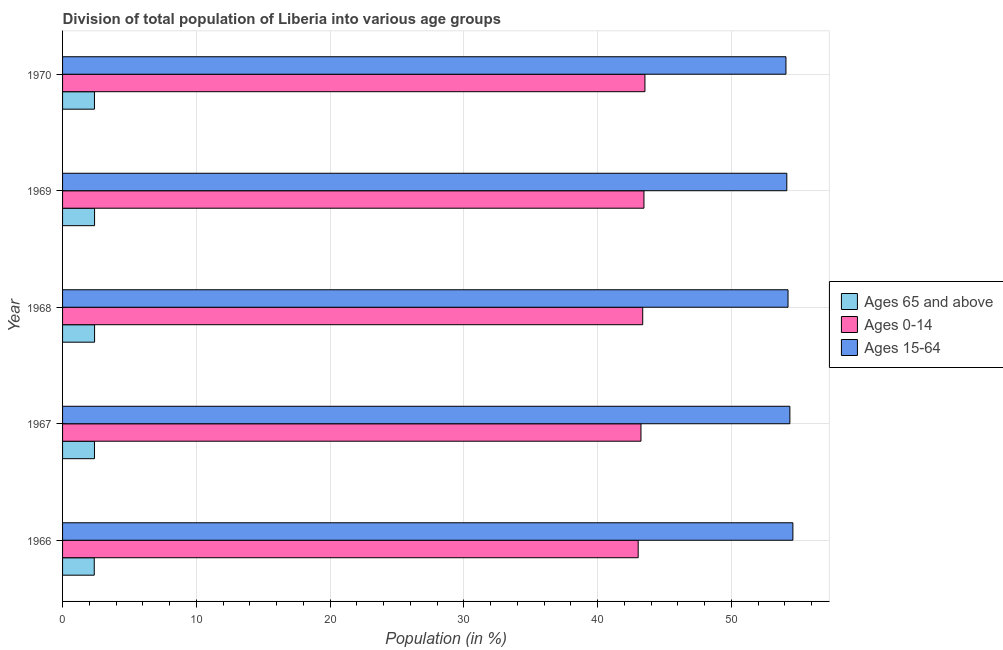How many different coloured bars are there?
Provide a succinct answer. 3. Are the number of bars per tick equal to the number of legend labels?
Offer a terse response. Yes. Are the number of bars on each tick of the Y-axis equal?
Provide a short and direct response. Yes. How many bars are there on the 1st tick from the bottom?
Your answer should be compact. 3. What is the label of the 1st group of bars from the top?
Offer a terse response. 1970. What is the percentage of population within the age-group 0-14 in 1970?
Provide a succinct answer. 43.54. Across all years, what is the maximum percentage of population within the age-group 15-64?
Provide a succinct answer. 54.6. Across all years, what is the minimum percentage of population within the age-group of 65 and above?
Provide a succinct answer. 2.37. In which year was the percentage of population within the age-group of 65 and above maximum?
Keep it short and to the point. 1968. In which year was the percentage of population within the age-group of 65 and above minimum?
Offer a terse response. 1966. What is the total percentage of population within the age-group 0-14 in the graph?
Give a very brief answer. 216.65. What is the difference between the percentage of population within the age-group 0-14 in 1968 and that in 1970?
Provide a short and direct response. -0.17. What is the difference between the percentage of population within the age-group 15-64 in 1970 and the percentage of population within the age-group 0-14 in 1966?
Keep it short and to the point. 11.05. What is the average percentage of population within the age-group 15-64 per year?
Provide a succinct answer. 54.29. In the year 1968, what is the difference between the percentage of population within the age-group 0-14 and percentage of population within the age-group of 65 and above?
Offer a very short reply. 40.98. In how many years, is the percentage of population within the age-group of 65 and above greater than 42 %?
Keep it short and to the point. 0. What is the ratio of the percentage of population within the age-group 0-14 in 1969 to that in 1970?
Provide a short and direct response. 1. Is the percentage of population within the age-group of 65 and above in 1968 less than that in 1969?
Ensure brevity in your answer.  No. What is the difference between the highest and the second highest percentage of population within the age-group 15-64?
Offer a very short reply. 0.23. What is the difference between the highest and the lowest percentage of population within the age-group of 65 and above?
Provide a short and direct response. 0.02. Is the sum of the percentage of population within the age-group of 65 and above in 1966 and 1969 greater than the maximum percentage of population within the age-group 15-64 across all years?
Give a very brief answer. No. What does the 1st bar from the top in 1969 represents?
Offer a very short reply. Ages 15-64. What does the 1st bar from the bottom in 1967 represents?
Keep it short and to the point. Ages 65 and above. How many bars are there?
Your answer should be compact. 15. How many years are there in the graph?
Offer a very short reply. 5. Are the values on the major ticks of X-axis written in scientific E-notation?
Offer a terse response. No. Does the graph contain any zero values?
Keep it short and to the point. No. Does the graph contain grids?
Make the answer very short. Yes. Where does the legend appear in the graph?
Offer a terse response. Center right. How are the legend labels stacked?
Make the answer very short. Vertical. What is the title of the graph?
Your answer should be very brief. Division of total population of Liberia into various age groups
. What is the label or title of the X-axis?
Your answer should be very brief. Population (in %). What is the Population (in %) of Ages 65 and above in 1966?
Your answer should be compact. 2.37. What is the Population (in %) of Ages 0-14 in 1966?
Make the answer very short. 43.03. What is the Population (in %) of Ages 15-64 in 1966?
Offer a very short reply. 54.6. What is the Population (in %) in Ages 65 and above in 1967?
Give a very brief answer. 2.39. What is the Population (in %) in Ages 0-14 in 1967?
Provide a short and direct response. 43.24. What is the Population (in %) of Ages 15-64 in 1967?
Your answer should be compact. 54.37. What is the Population (in %) in Ages 65 and above in 1968?
Offer a terse response. 2.39. What is the Population (in %) in Ages 0-14 in 1968?
Provide a succinct answer. 43.37. What is the Population (in %) in Ages 15-64 in 1968?
Offer a terse response. 54.23. What is the Population (in %) in Ages 65 and above in 1969?
Keep it short and to the point. 2.39. What is the Population (in %) in Ages 0-14 in 1969?
Make the answer very short. 43.46. What is the Population (in %) of Ages 15-64 in 1969?
Keep it short and to the point. 54.14. What is the Population (in %) of Ages 65 and above in 1970?
Your answer should be compact. 2.38. What is the Population (in %) of Ages 0-14 in 1970?
Offer a terse response. 43.54. What is the Population (in %) of Ages 15-64 in 1970?
Offer a terse response. 54.08. Across all years, what is the maximum Population (in %) in Ages 65 and above?
Make the answer very short. 2.39. Across all years, what is the maximum Population (in %) in Ages 0-14?
Keep it short and to the point. 43.54. Across all years, what is the maximum Population (in %) of Ages 15-64?
Offer a terse response. 54.6. Across all years, what is the minimum Population (in %) in Ages 65 and above?
Ensure brevity in your answer.  2.37. Across all years, what is the minimum Population (in %) in Ages 0-14?
Make the answer very short. 43.03. Across all years, what is the minimum Population (in %) in Ages 15-64?
Your answer should be compact. 54.08. What is the total Population (in %) in Ages 65 and above in the graph?
Provide a succinct answer. 11.92. What is the total Population (in %) in Ages 0-14 in the graph?
Ensure brevity in your answer.  216.65. What is the total Population (in %) in Ages 15-64 in the graph?
Make the answer very short. 271.43. What is the difference between the Population (in %) of Ages 65 and above in 1966 and that in 1967?
Keep it short and to the point. -0.02. What is the difference between the Population (in %) of Ages 0-14 in 1966 and that in 1967?
Make the answer very short. -0.21. What is the difference between the Population (in %) in Ages 15-64 in 1966 and that in 1967?
Ensure brevity in your answer.  0.23. What is the difference between the Population (in %) in Ages 65 and above in 1966 and that in 1968?
Your answer should be compact. -0.02. What is the difference between the Population (in %) in Ages 0-14 in 1966 and that in 1968?
Your answer should be very brief. -0.34. What is the difference between the Population (in %) of Ages 15-64 in 1966 and that in 1968?
Make the answer very short. 0.36. What is the difference between the Population (in %) of Ages 65 and above in 1966 and that in 1969?
Ensure brevity in your answer.  -0.02. What is the difference between the Population (in %) of Ages 0-14 in 1966 and that in 1969?
Give a very brief answer. -0.43. What is the difference between the Population (in %) in Ages 15-64 in 1966 and that in 1969?
Your answer should be compact. 0.45. What is the difference between the Population (in %) of Ages 65 and above in 1966 and that in 1970?
Offer a very short reply. -0.02. What is the difference between the Population (in %) in Ages 0-14 in 1966 and that in 1970?
Make the answer very short. -0.5. What is the difference between the Population (in %) in Ages 15-64 in 1966 and that in 1970?
Your response must be concise. 0.52. What is the difference between the Population (in %) in Ages 65 and above in 1967 and that in 1968?
Offer a very short reply. -0.01. What is the difference between the Population (in %) of Ages 0-14 in 1967 and that in 1968?
Your answer should be compact. -0.13. What is the difference between the Population (in %) of Ages 15-64 in 1967 and that in 1968?
Your answer should be compact. 0.14. What is the difference between the Population (in %) in Ages 65 and above in 1967 and that in 1969?
Offer a very short reply. -0.01. What is the difference between the Population (in %) of Ages 0-14 in 1967 and that in 1969?
Make the answer very short. -0.22. What is the difference between the Population (in %) in Ages 15-64 in 1967 and that in 1969?
Ensure brevity in your answer.  0.23. What is the difference between the Population (in %) of Ages 65 and above in 1967 and that in 1970?
Keep it short and to the point. 0. What is the difference between the Population (in %) of Ages 0-14 in 1967 and that in 1970?
Keep it short and to the point. -0.3. What is the difference between the Population (in %) of Ages 15-64 in 1967 and that in 1970?
Offer a terse response. 0.29. What is the difference between the Population (in %) in Ages 0-14 in 1968 and that in 1969?
Ensure brevity in your answer.  -0.09. What is the difference between the Population (in %) in Ages 15-64 in 1968 and that in 1969?
Your answer should be compact. 0.09. What is the difference between the Population (in %) in Ages 65 and above in 1968 and that in 1970?
Keep it short and to the point. 0.01. What is the difference between the Population (in %) of Ages 0-14 in 1968 and that in 1970?
Make the answer very short. -0.16. What is the difference between the Population (in %) in Ages 15-64 in 1968 and that in 1970?
Give a very brief answer. 0.16. What is the difference between the Population (in %) in Ages 65 and above in 1969 and that in 1970?
Your answer should be compact. 0.01. What is the difference between the Population (in %) in Ages 0-14 in 1969 and that in 1970?
Your answer should be very brief. -0.07. What is the difference between the Population (in %) in Ages 15-64 in 1969 and that in 1970?
Keep it short and to the point. 0.06. What is the difference between the Population (in %) in Ages 65 and above in 1966 and the Population (in %) in Ages 0-14 in 1967?
Your answer should be compact. -40.87. What is the difference between the Population (in %) of Ages 65 and above in 1966 and the Population (in %) of Ages 15-64 in 1967?
Offer a very short reply. -52. What is the difference between the Population (in %) of Ages 0-14 in 1966 and the Population (in %) of Ages 15-64 in 1967?
Ensure brevity in your answer.  -11.34. What is the difference between the Population (in %) in Ages 65 and above in 1966 and the Population (in %) in Ages 0-14 in 1968?
Provide a succinct answer. -41. What is the difference between the Population (in %) of Ages 65 and above in 1966 and the Population (in %) of Ages 15-64 in 1968?
Provide a short and direct response. -51.87. What is the difference between the Population (in %) of Ages 0-14 in 1966 and the Population (in %) of Ages 15-64 in 1968?
Provide a short and direct response. -11.2. What is the difference between the Population (in %) of Ages 65 and above in 1966 and the Population (in %) of Ages 0-14 in 1969?
Your response must be concise. -41.09. What is the difference between the Population (in %) of Ages 65 and above in 1966 and the Population (in %) of Ages 15-64 in 1969?
Your response must be concise. -51.78. What is the difference between the Population (in %) of Ages 0-14 in 1966 and the Population (in %) of Ages 15-64 in 1969?
Your answer should be very brief. -11.11. What is the difference between the Population (in %) of Ages 65 and above in 1966 and the Population (in %) of Ages 0-14 in 1970?
Offer a very short reply. -41.17. What is the difference between the Population (in %) in Ages 65 and above in 1966 and the Population (in %) in Ages 15-64 in 1970?
Make the answer very short. -51.71. What is the difference between the Population (in %) of Ages 0-14 in 1966 and the Population (in %) of Ages 15-64 in 1970?
Offer a terse response. -11.05. What is the difference between the Population (in %) of Ages 65 and above in 1967 and the Population (in %) of Ages 0-14 in 1968?
Give a very brief answer. -40.99. What is the difference between the Population (in %) in Ages 65 and above in 1967 and the Population (in %) in Ages 15-64 in 1968?
Your answer should be very brief. -51.85. What is the difference between the Population (in %) in Ages 0-14 in 1967 and the Population (in %) in Ages 15-64 in 1968?
Make the answer very short. -10.99. What is the difference between the Population (in %) in Ages 65 and above in 1967 and the Population (in %) in Ages 0-14 in 1969?
Your answer should be compact. -41.08. What is the difference between the Population (in %) of Ages 65 and above in 1967 and the Population (in %) of Ages 15-64 in 1969?
Ensure brevity in your answer.  -51.76. What is the difference between the Population (in %) of Ages 0-14 in 1967 and the Population (in %) of Ages 15-64 in 1969?
Offer a terse response. -10.9. What is the difference between the Population (in %) of Ages 65 and above in 1967 and the Population (in %) of Ages 0-14 in 1970?
Your response must be concise. -41.15. What is the difference between the Population (in %) of Ages 65 and above in 1967 and the Population (in %) of Ages 15-64 in 1970?
Make the answer very short. -51.69. What is the difference between the Population (in %) in Ages 0-14 in 1967 and the Population (in %) in Ages 15-64 in 1970?
Ensure brevity in your answer.  -10.84. What is the difference between the Population (in %) in Ages 65 and above in 1968 and the Population (in %) in Ages 0-14 in 1969?
Your answer should be compact. -41.07. What is the difference between the Population (in %) in Ages 65 and above in 1968 and the Population (in %) in Ages 15-64 in 1969?
Give a very brief answer. -51.75. What is the difference between the Population (in %) of Ages 0-14 in 1968 and the Population (in %) of Ages 15-64 in 1969?
Provide a succinct answer. -10.77. What is the difference between the Population (in %) in Ages 65 and above in 1968 and the Population (in %) in Ages 0-14 in 1970?
Your response must be concise. -41.14. What is the difference between the Population (in %) in Ages 65 and above in 1968 and the Population (in %) in Ages 15-64 in 1970?
Provide a succinct answer. -51.69. What is the difference between the Population (in %) of Ages 0-14 in 1968 and the Population (in %) of Ages 15-64 in 1970?
Keep it short and to the point. -10.71. What is the difference between the Population (in %) in Ages 65 and above in 1969 and the Population (in %) in Ages 0-14 in 1970?
Offer a very short reply. -41.14. What is the difference between the Population (in %) in Ages 65 and above in 1969 and the Population (in %) in Ages 15-64 in 1970?
Your answer should be very brief. -51.69. What is the difference between the Population (in %) in Ages 0-14 in 1969 and the Population (in %) in Ages 15-64 in 1970?
Keep it short and to the point. -10.62. What is the average Population (in %) in Ages 65 and above per year?
Make the answer very short. 2.38. What is the average Population (in %) of Ages 0-14 per year?
Keep it short and to the point. 43.33. What is the average Population (in %) of Ages 15-64 per year?
Provide a short and direct response. 54.29. In the year 1966, what is the difference between the Population (in %) in Ages 65 and above and Population (in %) in Ages 0-14?
Provide a succinct answer. -40.66. In the year 1966, what is the difference between the Population (in %) in Ages 65 and above and Population (in %) in Ages 15-64?
Ensure brevity in your answer.  -52.23. In the year 1966, what is the difference between the Population (in %) in Ages 0-14 and Population (in %) in Ages 15-64?
Your answer should be compact. -11.57. In the year 1967, what is the difference between the Population (in %) in Ages 65 and above and Population (in %) in Ages 0-14?
Give a very brief answer. -40.86. In the year 1967, what is the difference between the Population (in %) of Ages 65 and above and Population (in %) of Ages 15-64?
Make the answer very short. -51.99. In the year 1967, what is the difference between the Population (in %) of Ages 0-14 and Population (in %) of Ages 15-64?
Provide a succinct answer. -11.13. In the year 1968, what is the difference between the Population (in %) of Ages 65 and above and Population (in %) of Ages 0-14?
Your answer should be compact. -40.98. In the year 1968, what is the difference between the Population (in %) of Ages 65 and above and Population (in %) of Ages 15-64?
Your answer should be compact. -51.84. In the year 1968, what is the difference between the Population (in %) in Ages 0-14 and Population (in %) in Ages 15-64?
Make the answer very short. -10.86. In the year 1969, what is the difference between the Population (in %) in Ages 65 and above and Population (in %) in Ages 0-14?
Make the answer very short. -41.07. In the year 1969, what is the difference between the Population (in %) of Ages 65 and above and Population (in %) of Ages 15-64?
Keep it short and to the point. -51.75. In the year 1969, what is the difference between the Population (in %) in Ages 0-14 and Population (in %) in Ages 15-64?
Ensure brevity in your answer.  -10.68. In the year 1970, what is the difference between the Population (in %) in Ages 65 and above and Population (in %) in Ages 0-14?
Your answer should be very brief. -41.15. In the year 1970, what is the difference between the Population (in %) of Ages 65 and above and Population (in %) of Ages 15-64?
Keep it short and to the point. -51.7. In the year 1970, what is the difference between the Population (in %) of Ages 0-14 and Population (in %) of Ages 15-64?
Keep it short and to the point. -10.54. What is the ratio of the Population (in %) of Ages 65 and above in 1966 to that in 1968?
Offer a terse response. 0.99. What is the ratio of the Population (in %) of Ages 0-14 in 1966 to that in 1968?
Offer a terse response. 0.99. What is the ratio of the Population (in %) of Ages 15-64 in 1966 to that in 1968?
Your answer should be compact. 1.01. What is the ratio of the Population (in %) in Ages 65 and above in 1966 to that in 1969?
Give a very brief answer. 0.99. What is the ratio of the Population (in %) in Ages 15-64 in 1966 to that in 1969?
Ensure brevity in your answer.  1.01. What is the ratio of the Population (in %) in Ages 65 and above in 1966 to that in 1970?
Give a very brief answer. 0.99. What is the ratio of the Population (in %) of Ages 0-14 in 1966 to that in 1970?
Give a very brief answer. 0.99. What is the ratio of the Population (in %) in Ages 15-64 in 1966 to that in 1970?
Provide a short and direct response. 1.01. What is the ratio of the Population (in %) in Ages 65 and above in 1967 to that in 1969?
Provide a succinct answer. 1. What is the ratio of the Population (in %) of Ages 15-64 in 1967 to that in 1969?
Your answer should be very brief. 1. What is the ratio of the Population (in %) in Ages 65 and above in 1967 to that in 1970?
Offer a very short reply. 1. What is the ratio of the Population (in %) of Ages 15-64 in 1967 to that in 1970?
Offer a very short reply. 1.01. What is the ratio of the Population (in %) of Ages 65 and above in 1968 to that in 1970?
Your answer should be very brief. 1. What is the ratio of the Population (in %) in Ages 0-14 in 1968 to that in 1970?
Give a very brief answer. 1. What is the ratio of the Population (in %) in Ages 15-64 in 1969 to that in 1970?
Give a very brief answer. 1. What is the difference between the highest and the second highest Population (in %) of Ages 0-14?
Make the answer very short. 0.07. What is the difference between the highest and the second highest Population (in %) in Ages 15-64?
Offer a very short reply. 0.23. What is the difference between the highest and the lowest Population (in %) in Ages 65 and above?
Ensure brevity in your answer.  0.02. What is the difference between the highest and the lowest Population (in %) of Ages 0-14?
Make the answer very short. 0.5. What is the difference between the highest and the lowest Population (in %) in Ages 15-64?
Make the answer very short. 0.52. 